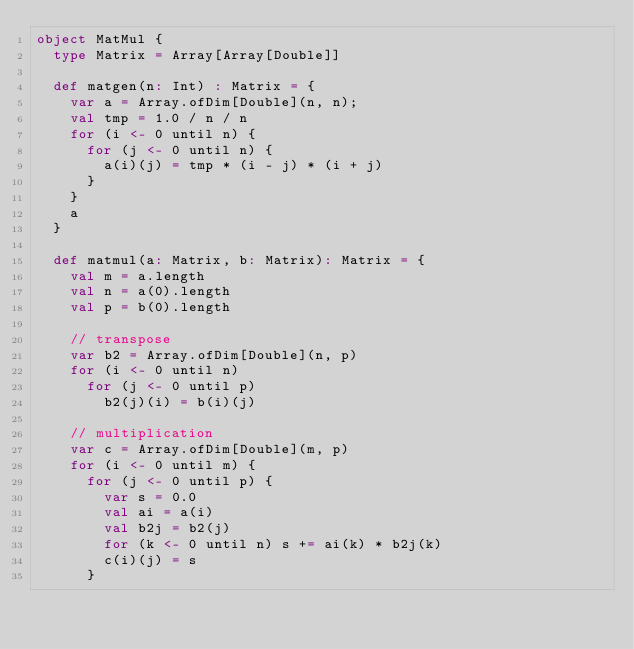Convert code to text. <code><loc_0><loc_0><loc_500><loc_500><_Scala_>object MatMul {
  type Matrix = Array[Array[Double]]

  def matgen(n: Int) : Matrix = {
    var a = Array.ofDim[Double](n, n);
    val tmp = 1.0 / n / n
    for (i <- 0 until n) {
      for (j <- 0 until n) {
        a(i)(j) = tmp * (i - j) * (i + j)
      }
    }
    a
  }

  def matmul(a: Matrix, b: Matrix): Matrix = {
    val m = a.length
    val n = a(0).length
    val p = b(0).length

    // transpose
    var b2 = Array.ofDim[Double](n, p)
    for (i <- 0 until n)
      for (j <- 0 until p)
        b2(j)(i) = b(i)(j)

    // multiplication
    var c = Array.ofDim[Double](m, p)
    for (i <- 0 until m) {
      for (j <- 0 until p) {
        var s = 0.0
        val ai = a(i)
        val b2j = b2(j)
        for (k <- 0 until n) s += ai(k) * b2j(k)
        c(i)(j) = s
      }</code> 